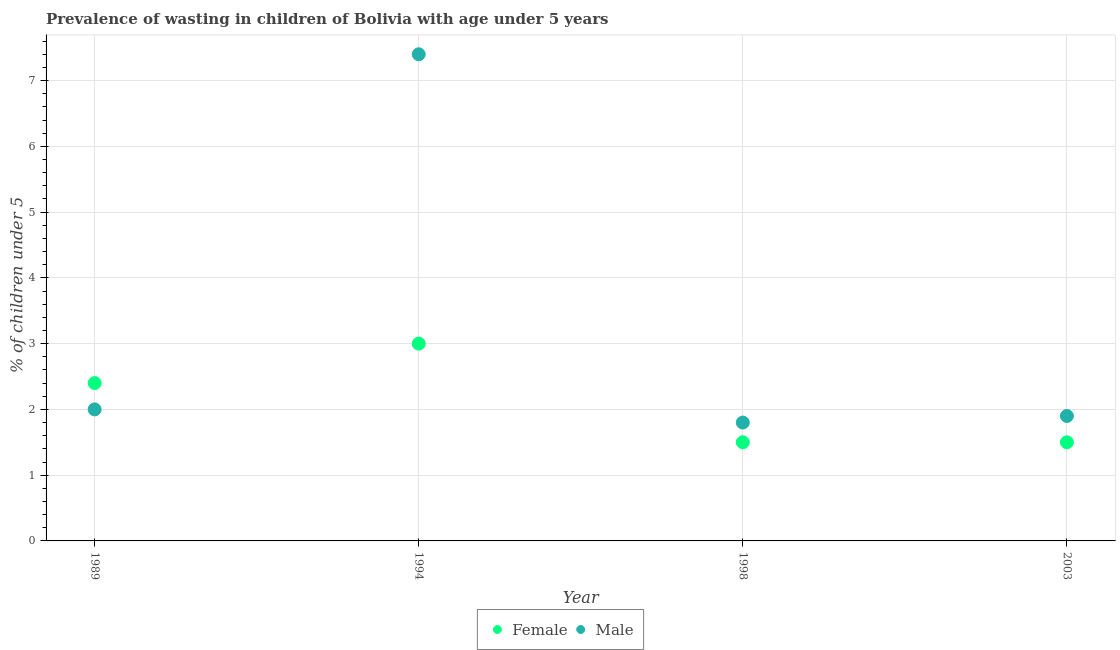What is the percentage of undernourished male children in 2003?
Provide a succinct answer. 1.9. In which year was the percentage of undernourished female children minimum?
Offer a terse response. 1998. What is the total percentage of undernourished female children in the graph?
Keep it short and to the point. 8.4. What is the difference between the percentage of undernourished female children in 1994 and the percentage of undernourished male children in 1998?
Your answer should be compact. 1.2. What is the average percentage of undernourished female children per year?
Offer a very short reply. 2.1. In the year 1994, what is the difference between the percentage of undernourished male children and percentage of undernourished female children?
Ensure brevity in your answer.  4.4. Is the difference between the percentage of undernourished male children in 1989 and 1994 greater than the difference between the percentage of undernourished female children in 1989 and 1994?
Provide a succinct answer. No. What is the difference between the highest and the second highest percentage of undernourished male children?
Your answer should be compact. 5.4. What is the difference between the highest and the lowest percentage of undernourished female children?
Ensure brevity in your answer.  1.5. In how many years, is the percentage of undernourished male children greater than the average percentage of undernourished male children taken over all years?
Give a very brief answer. 1. Is the percentage of undernourished male children strictly greater than the percentage of undernourished female children over the years?
Your answer should be very brief. No. Is the percentage of undernourished female children strictly less than the percentage of undernourished male children over the years?
Give a very brief answer. No. How many dotlines are there?
Give a very brief answer. 2. Are the values on the major ticks of Y-axis written in scientific E-notation?
Provide a succinct answer. No. How are the legend labels stacked?
Your response must be concise. Horizontal. What is the title of the graph?
Offer a terse response. Prevalence of wasting in children of Bolivia with age under 5 years. What is the label or title of the Y-axis?
Provide a succinct answer.  % of children under 5. What is the  % of children under 5 of Female in 1989?
Your answer should be compact. 2.4. What is the  % of children under 5 of Male in 1989?
Offer a very short reply. 2. What is the  % of children under 5 of Female in 1994?
Offer a terse response. 3. What is the  % of children under 5 in Male in 1994?
Provide a short and direct response. 7.4. What is the  % of children under 5 of Male in 1998?
Your answer should be very brief. 1.8. What is the  % of children under 5 in Male in 2003?
Provide a short and direct response. 1.9. Across all years, what is the maximum  % of children under 5 of Female?
Keep it short and to the point. 3. Across all years, what is the maximum  % of children under 5 in Male?
Ensure brevity in your answer.  7.4. Across all years, what is the minimum  % of children under 5 of Male?
Your response must be concise. 1.8. What is the total  % of children under 5 of Female in the graph?
Give a very brief answer. 8.4. What is the difference between the  % of children under 5 of Male in 1989 and that in 2003?
Provide a succinct answer. 0.1. What is the difference between the  % of children under 5 in Female in 1994 and that in 1998?
Your response must be concise. 1.5. What is the difference between the  % of children under 5 in Male in 1994 and that in 1998?
Keep it short and to the point. 5.6. What is the difference between the  % of children under 5 of Male in 1994 and that in 2003?
Your answer should be very brief. 5.5. What is the difference between the  % of children under 5 of Male in 1998 and that in 2003?
Offer a very short reply. -0.1. What is the difference between the  % of children under 5 in Female in 1989 and the  % of children under 5 in Male in 1998?
Ensure brevity in your answer.  0.6. What is the difference between the  % of children under 5 of Female in 1994 and the  % of children under 5 of Male in 1998?
Provide a short and direct response. 1.2. What is the difference between the  % of children under 5 in Female in 1998 and the  % of children under 5 in Male in 2003?
Your answer should be very brief. -0.4. What is the average  % of children under 5 of Male per year?
Provide a short and direct response. 3.27. In the year 1989, what is the difference between the  % of children under 5 of Female and  % of children under 5 of Male?
Provide a succinct answer. 0.4. In the year 1994, what is the difference between the  % of children under 5 in Female and  % of children under 5 in Male?
Keep it short and to the point. -4.4. What is the ratio of the  % of children under 5 of Female in 1989 to that in 1994?
Offer a very short reply. 0.8. What is the ratio of the  % of children under 5 in Male in 1989 to that in 1994?
Your response must be concise. 0.27. What is the ratio of the  % of children under 5 of Male in 1989 to that in 2003?
Offer a terse response. 1.05. What is the ratio of the  % of children under 5 in Male in 1994 to that in 1998?
Provide a short and direct response. 4.11. What is the ratio of the  % of children under 5 of Female in 1994 to that in 2003?
Offer a terse response. 2. What is the ratio of the  % of children under 5 in Male in 1994 to that in 2003?
Provide a short and direct response. 3.89. What is the ratio of the  % of children under 5 in Male in 1998 to that in 2003?
Keep it short and to the point. 0.95. What is the difference between the highest and the second highest  % of children under 5 of Male?
Offer a very short reply. 5.4. What is the difference between the highest and the lowest  % of children under 5 of Female?
Your response must be concise. 1.5. What is the difference between the highest and the lowest  % of children under 5 in Male?
Provide a succinct answer. 5.6. 